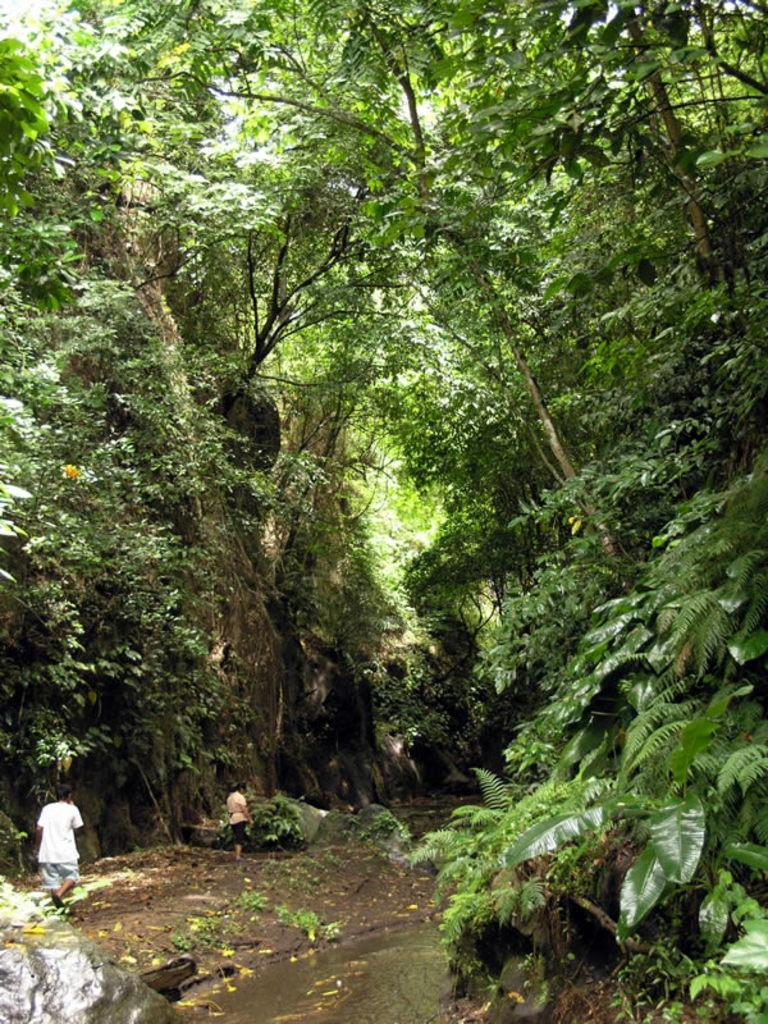How many people are in the foreground of the image? There are two persons in the foreground of the image. What is the location of the persons in the image? The persons are on the ground and water in the image. What can be seen in the background of the image? There are trees, grass, a rock, and the sky visible in the background of the image. Can you describe the time of day when the image was likely taken? The image was likely taken during the day, as the sky is visible and there is sufficient light. What type of bean is being used as a boundary in the image? There is no bean present in the image, nor is there any indication of a boundary. 